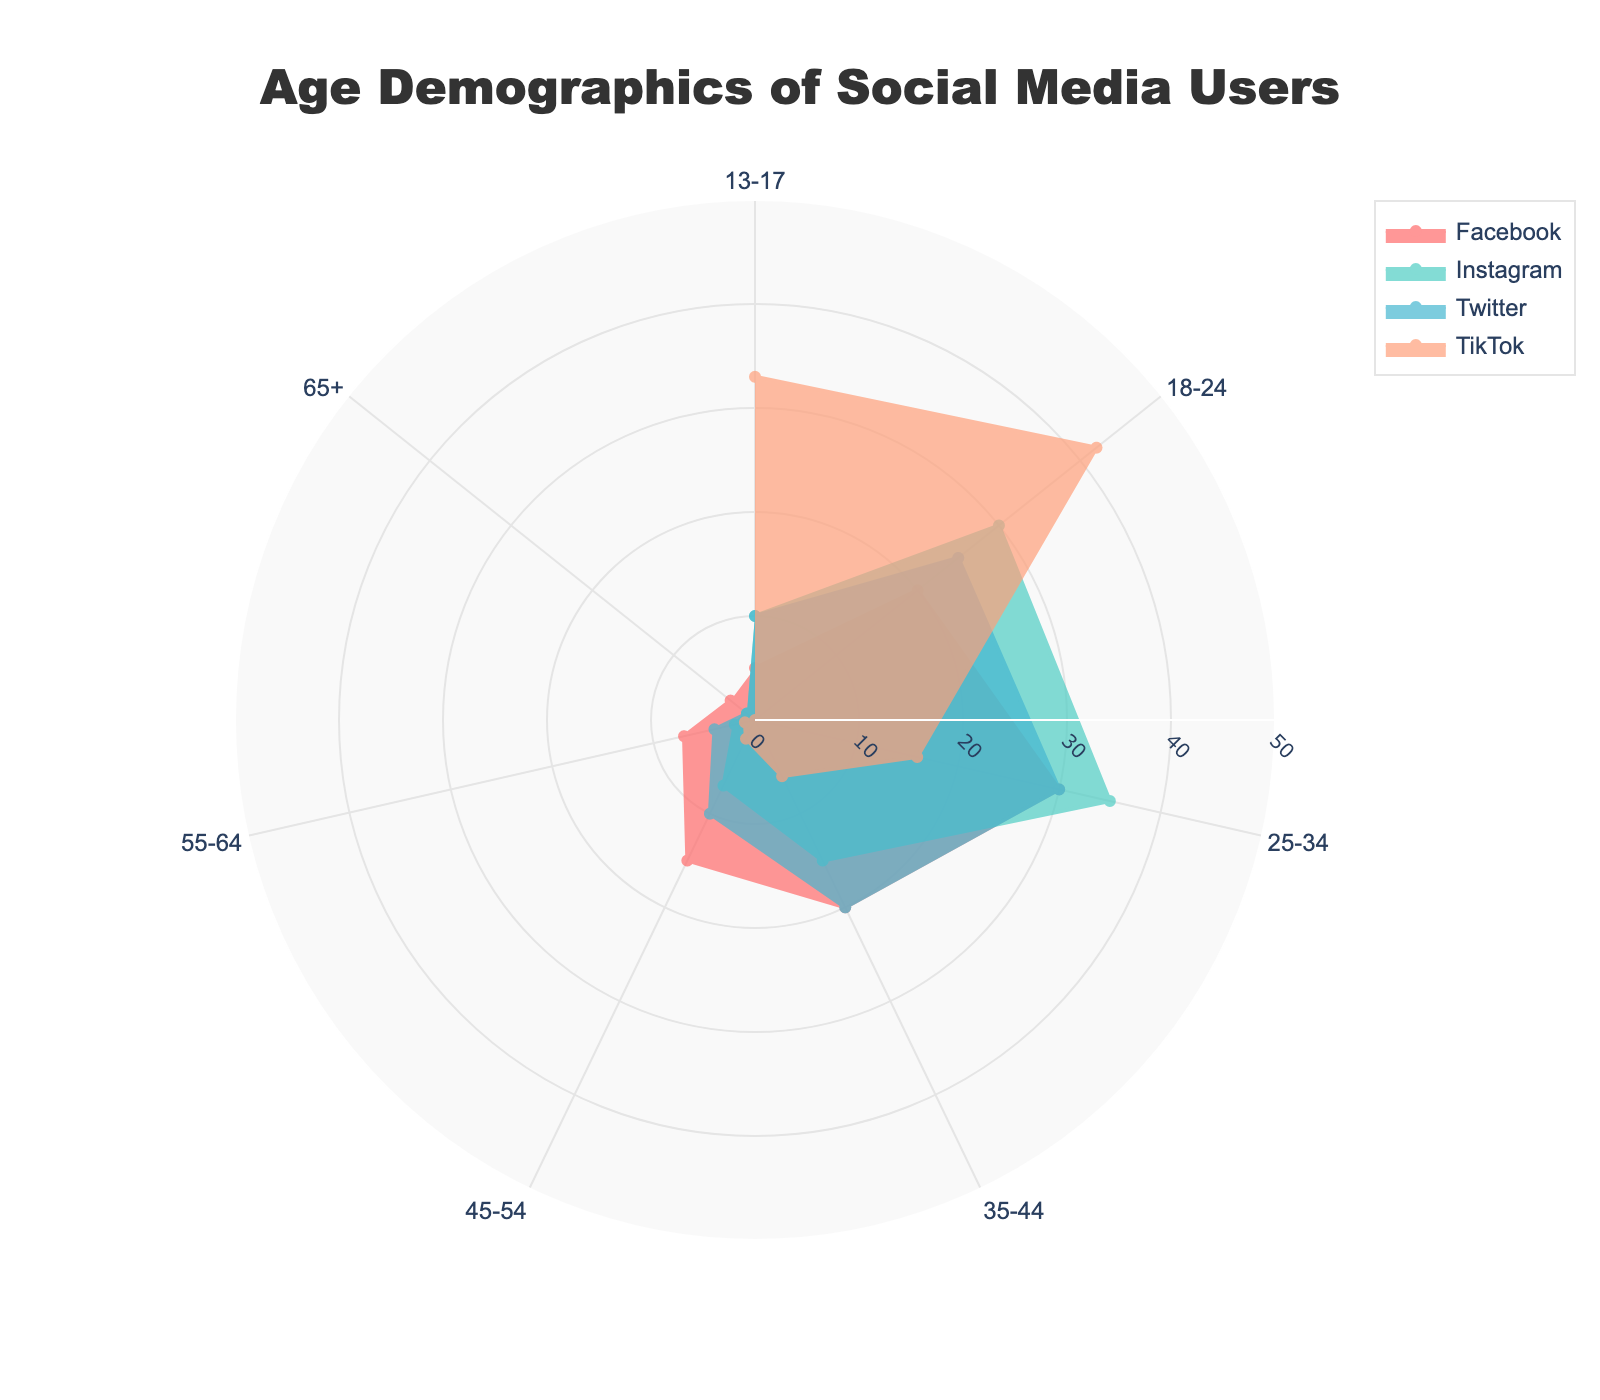What is the main title of the figure? The main title of the figure is located at the top center and reads "Age Demographics of Social Media Users."
Answer: Age Demographics of Social Media Users How many age groups are represented in the chart? Look around the outside of the polar chart; there are labels for 7 age groups.
Answer: 7 Which platform has the highest percentage of users aged 18-24? Check the radial axis value for the 18-24 age group and compare across all platforms. TikTok has the highest percentage at 42%.
Answer: TikTok Which age group has the smallest percentage of TikTok users? Look at the radial lengths for all age groups that correspond to TikTok. The smallest percentage is for age 65+ at 0%.
Answer: 65+ What is the combined percentage of Facebook users in the 25-34 and 35-44 age groups? From the figure, add the percentage of Facebook users in the 25-34 and 35-44 groups: 30% + 20%.
Answer: 50% How does Instagram's user percentage in the 25-34 age group compare to Twitter's user percentage in the same age group? Compare the radial values for the 25-34 age group for Instagram and Twitter. Instagram has 35%, which is higher than Twitter's 30%.
Answer: Instagram is higher Which platform has the most balanced age distribution? Look at the radial lengths for all age groups for each platform to see how evenly the percentages are distributed. Facebook appears most balanced across age groups.
Answer: Facebook What percentage of Twitter users are younger than 25 (combining 13-17 and 18-24 groups)? Add the percentages for the 13-17 and 18-24 age groups for Twitter: 10% + 25%.
Answer: 35% By how much does TikTok's percentage of users aged 13-17 exceed that of Facebook? Subtract Facebook's percentage of users aged 13-17 from TikTok's percentage: 33% - 5%.
Answer: 28% What is the percentage share of Instagram users aged 45-54 compared to the same group on Facebook? Compare the radial values for the 45-54 age group on Instagram and Facebook. Instagram has 7%, while Facebook has 15%.
Answer: 7% vs 15% 